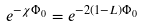<formula> <loc_0><loc_0><loc_500><loc_500>e ^ { - \chi \Phi _ { 0 } } = e ^ { - 2 ( 1 - L ) \Phi _ { 0 } }</formula> 